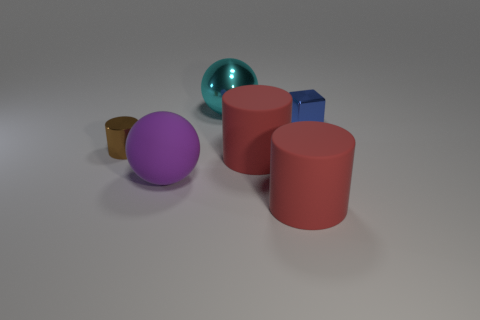Add 3 small cylinders. How many objects exist? 9 Subtract all spheres. How many objects are left? 4 Add 5 big cyan things. How many big cyan things are left? 6 Add 1 big spheres. How many big spheres exist? 3 Subtract 1 brown cylinders. How many objects are left? 5 Subtract all big cyan spheres. Subtract all large red rubber cylinders. How many objects are left? 3 